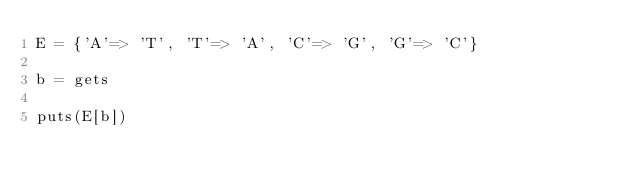Convert code to text. <code><loc_0><loc_0><loc_500><loc_500><_Ruby_>E = {'A'=> 'T', 'T'=> 'A', 'C'=> 'G', 'G'=> 'C'}

b = gets

puts(E[b])
</code> 